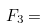<formula> <loc_0><loc_0><loc_500><loc_500>F _ { 3 } =</formula> 